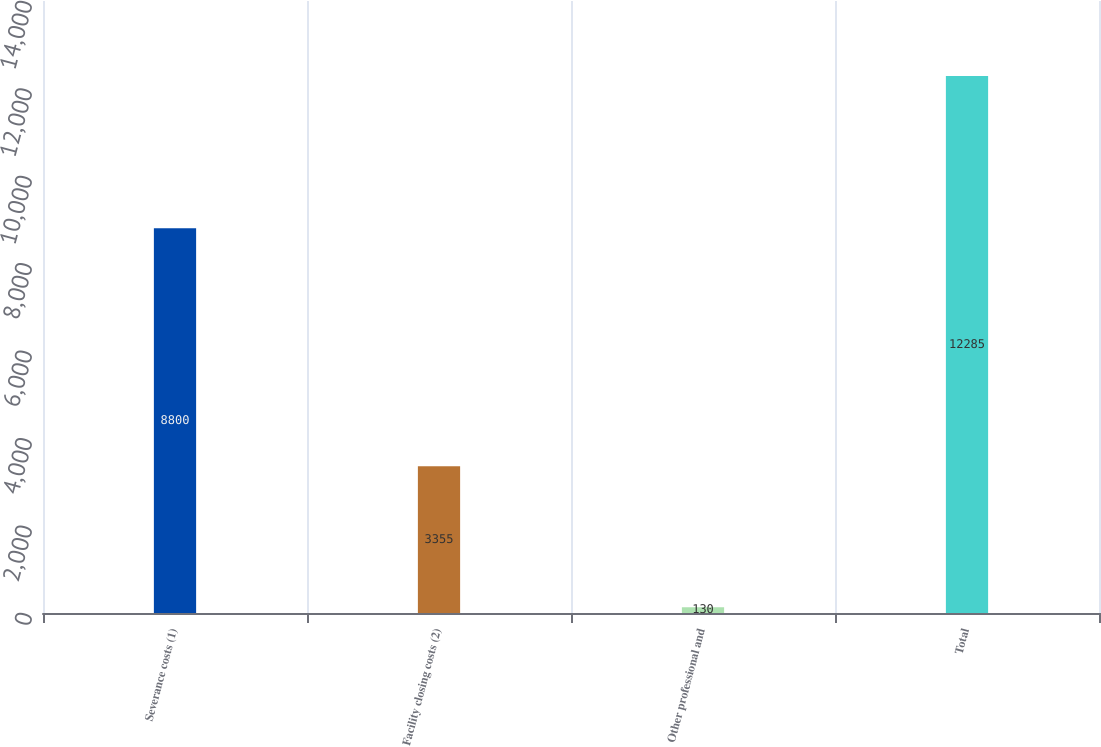Convert chart. <chart><loc_0><loc_0><loc_500><loc_500><bar_chart><fcel>Severance costs (1)<fcel>Facility closing costs (2)<fcel>Other professional and<fcel>Total<nl><fcel>8800<fcel>3355<fcel>130<fcel>12285<nl></chart> 